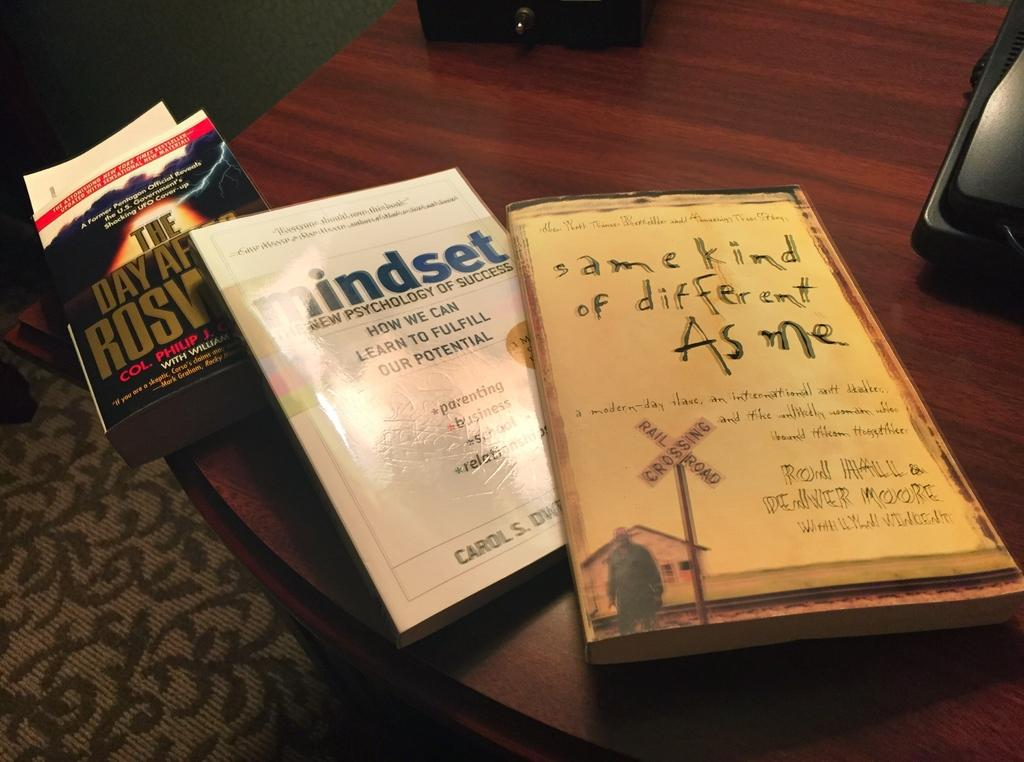<image>
Summarize the visual content of the image. The middle book in white sitting on the table in named Mindset. 